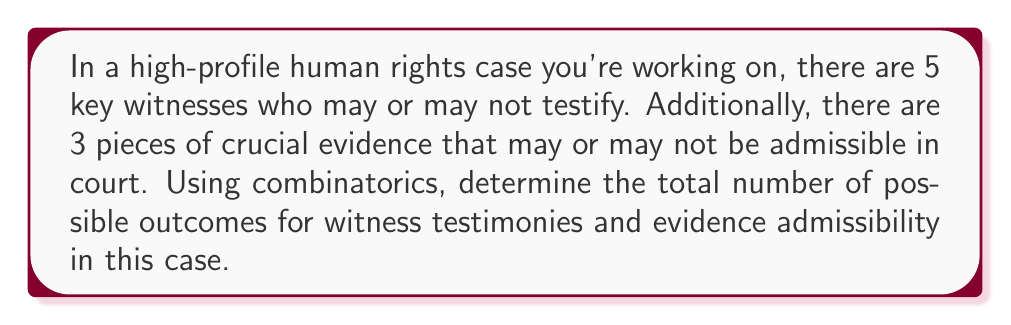Can you solve this math problem? To solve this problem, we'll use the multiplication principle of combinatorics. Let's break down the problem into two parts:

1. Witness testimonies:
   Each witness has two options: to testify or not to testify. This can be represented as a binary choice for each witness. With 5 witnesses, we have 2 choices for each of the 5 positions.

   Number of witness combinations = $2^5$

2. Evidence admissibility:
   Each piece of evidence has two options: admissible or not admissible. With 3 pieces of evidence, we again have 2 choices for each of the 3 positions.

   Number of evidence combinations = $2^3$

Now, to find the total number of possible outcomes, we multiply these two results together:

Total outcomes = (Witness combinations) × (Evidence combinations)
                = $2^5 \times 2^3$
                = $2^8$
                = 256

We can also think of this as having 8 independent binary choices (5 for witnesses + 3 for evidence), which gives us $2^8$ total combinations.
Answer: The total number of possible outcomes for witness testimonies and evidence admissibility in this case is 256. 